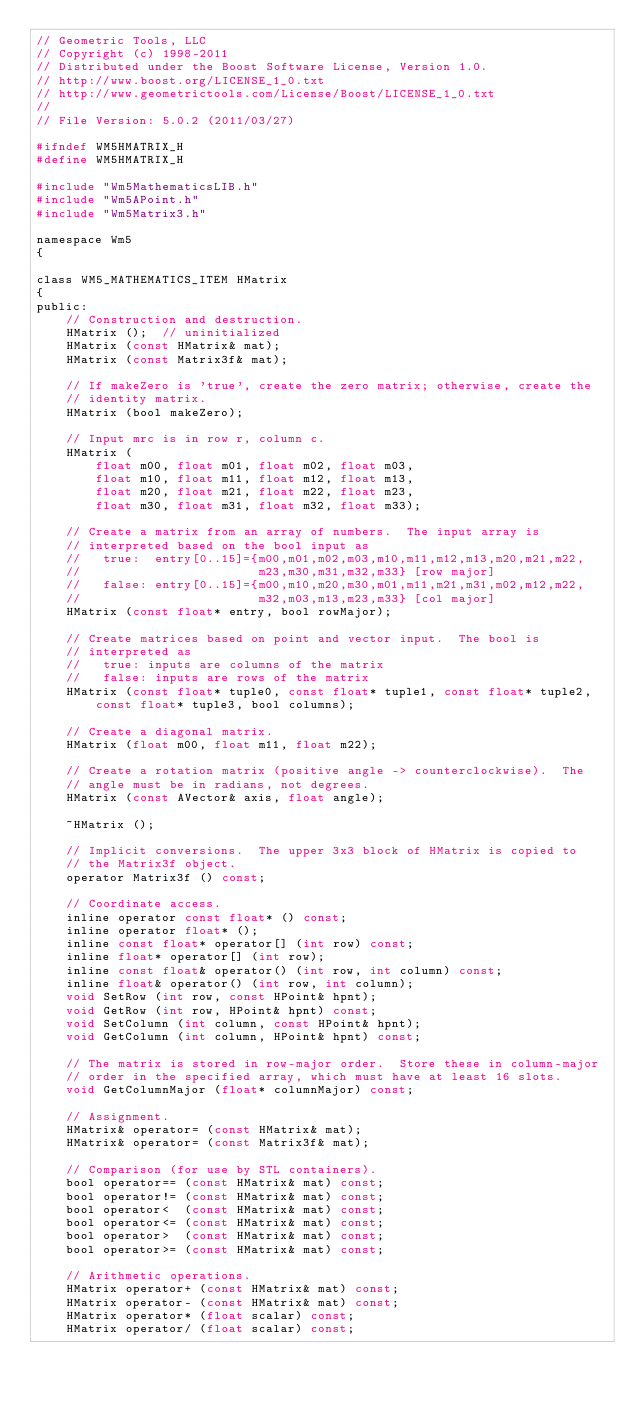<code> <loc_0><loc_0><loc_500><loc_500><_C_>// Geometric Tools, LLC
// Copyright (c) 1998-2011
// Distributed under the Boost Software License, Version 1.0.
// http://www.boost.org/LICENSE_1_0.txt
// http://www.geometrictools.com/License/Boost/LICENSE_1_0.txt
//
// File Version: 5.0.2 (2011/03/27)

#ifndef WM5HMATRIX_H
#define WM5HMATRIX_H

#include "Wm5MathematicsLIB.h"
#include "Wm5APoint.h"
#include "Wm5Matrix3.h"

namespace Wm5
{

class WM5_MATHEMATICS_ITEM HMatrix
{
public:
    // Construction and destruction.
    HMatrix ();  // uninitialized
    HMatrix (const HMatrix& mat);
    HMatrix (const Matrix3f& mat);

    // If makeZero is 'true', create the zero matrix; otherwise, create the
    // identity matrix.
    HMatrix (bool makeZero);

    // Input mrc is in row r, column c.
    HMatrix (
        float m00, float m01, float m02, float m03,
        float m10, float m11, float m12, float m13,
        float m20, float m21, float m22, float m23,
        float m30, float m31, float m32, float m33);

    // Create a matrix from an array of numbers.  The input array is
    // interpreted based on the bool input as
    //   true:  entry[0..15]={m00,m01,m02,m03,m10,m11,m12,m13,m20,m21,m22,
    //                        m23,m30,m31,m32,m33} [row major]
    //   false: entry[0..15]={m00,m10,m20,m30,m01,m11,m21,m31,m02,m12,m22,
    //                        m32,m03,m13,m23,m33} [col major]
    HMatrix (const float* entry, bool rowMajor);

    // Create matrices based on point and vector input.  The bool is
    // interpreted as
    //   true: inputs are columns of the matrix
    //   false: inputs are rows of the matrix
    HMatrix (const float* tuple0, const float* tuple1, const float* tuple2,
        const float* tuple3, bool columns);

    // Create a diagonal matrix.
    HMatrix (float m00, float m11, float m22);

    // Create a rotation matrix (positive angle -> counterclockwise).  The
    // angle must be in radians, not degrees.
    HMatrix (const AVector& axis, float angle);

    ~HMatrix ();

    // Implicit conversions.  The upper 3x3 block of HMatrix is copied to
    // the Matrix3f object.
    operator Matrix3f () const;

    // Coordinate access.
    inline operator const float* () const;
    inline operator float* ();
    inline const float* operator[] (int row) const;
    inline float* operator[] (int row);
    inline const float& operator() (int row, int column) const;
    inline float& operator() (int row, int column);
    void SetRow (int row, const HPoint& hpnt);
    void GetRow (int row, HPoint& hpnt) const;
    void SetColumn (int column, const HPoint& hpnt);
    void GetColumn (int column, HPoint& hpnt) const;

    // The matrix is stored in row-major order.  Store these in column-major
    // order in the specified array, which must have at least 16 slots.
    void GetColumnMajor (float* columnMajor) const;

    // Assignment.
    HMatrix& operator= (const HMatrix& mat);
    HMatrix& operator= (const Matrix3f& mat);

    // Comparison (for use by STL containers).
    bool operator== (const HMatrix& mat) const;
    bool operator!= (const HMatrix& mat) const;
    bool operator<  (const HMatrix& mat) const;
    bool operator<= (const HMatrix& mat) const;
    bool operator>  (const HMatrix& mat) const;
    bool operator>= (const HMatrix& mat) const;

    // Arithmetic operations.
    HMatrix operator+ (const HMatrix& mat) const;
    HMatrix operator- (const HMatrix& mat) const;
    HMatrix operator* (float scalar) const;
    HMatrix operator/ (float scalar) const;</code> 